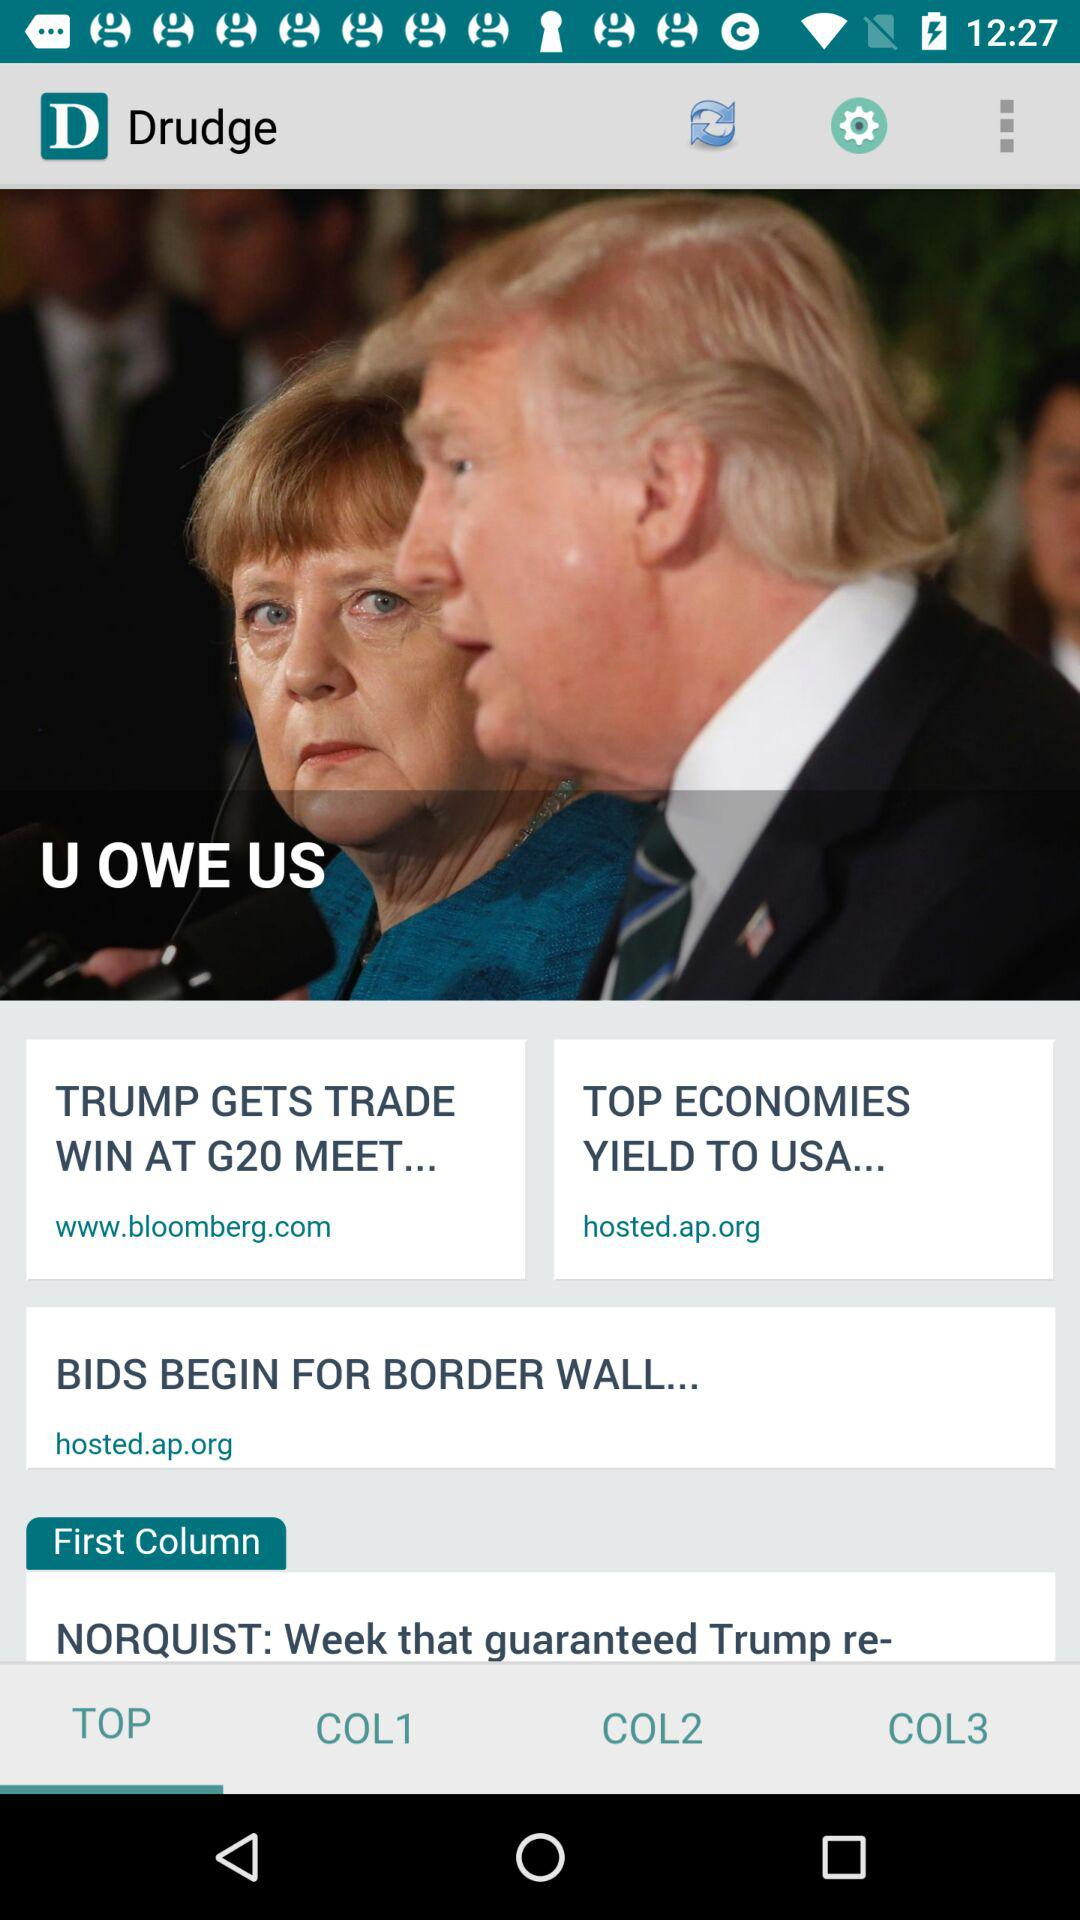Which tab is selected? The selected tab is "TOP". 